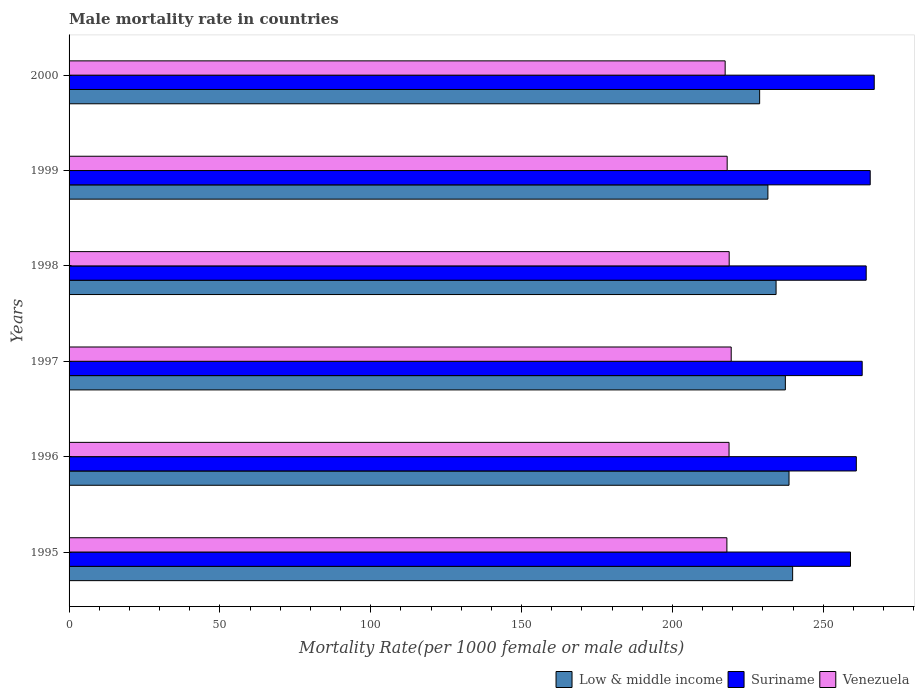Are the number of bars per tick equal to the number of legend labels?
Keep it short and to the point. Yes. How many bars are there on the 4th tick from the top?
Ensure brevity in your answer.  3. How many bars are there on the 2nd tick from the bottom?
Offer a very short reply. 3. In how many cases, is the number of bars for a given year not equal to the number of legend labels?
Offer a very short reply. 0. What is the male mortality rate in Suriname in 1999?
Offer a terse response. 265.58. Across all years, what is the maximum male mortality rate in Low & middle income?
Your answer should be compact. 239.86. Across all years, what is the minimum male mortality rate in Venezuela?
Your answer should be very brief. 217.49. In which year was the male mortality rate in Low & middle income maximum?
Your response must be concise. 1995. What is the total male mortality rate in Suriname in the graph?
Offer a terse response. 1579.68. What is the difference between the male mortality rate in Venezuela in 1996 and that in 2000?
Keep it short and to the point. 1.29. What is the difference between the male mortality rate in Low & middle income in 1997 and the male mortality rate in Suriname in 1999?
Offer a terse response. -28.13. What is the average male mortality rate in Venezuela per year?
Ensure brevity in your answer.  218.47. In the year 1998, what is the difference between the male mortality rate in Venezuela and male mortality rate in Low & middle income?
Give a very brief answer. -15.54. What is the ratio of the male mortality rate in Suriname in 1995 to that in 1999?
Provide a succinct answer. 0.98. Is the male mortality rate in Low & middle income in 1995 less than that in 1997?
Ensure brevity in your answer.  No. Is the difference between the male mortality rate in Venezuela in 1997 and 2000 greater than the difference between the male mortality rate in Low & middle income in 1997 and 2000?
Offer a terse response. No. What is the difference between the highest and the second highest male mortality rate in Venezuela?
Make the answer very short. 0.67. What is the difference between the highest and the lowest male mortality rate in Suriname?
Your answer should be very brief. 7.87. Is the sum of the male mortality rate in Suriname in 1997 and 2000 greater than the maximum male mortality rate in Venezuela across all years?
Provide a short and direct response. Yes. What does the 2nd bar from the top in 1996 represents?
Your answer should be compact. Suriname. What does the 2nd bar from the bottom in 1996 represents?
Your response must be concise. Suriname. What is the difference between two consecutive major ticks on the X-axis?
Give a very brief answer. 50. Does the graph contain any zero values?
Give a very brief answer. No. How many legend labels are there?
Offer a very short reply. 3. What is the title of the graph?
Your response must be concise. Male mortality rate in countries. Does "American Samoa" appear as one of the legend labels in the graph?
Keep it short and to the point. No. What is the label or title of the X-axis?
Offer a terse response. Mortality Rate(per 1000 female or male adults). What is the Mortality Rate(per 1000 female or male adults) in Low & middle income in 1995?
Offer a terse response. 239.86. What is the Mortality Rate(per 1000 female or male adults) of Suriname in 1995?
Offer a very short reply. 259.04. What is the Mortality Rate(per 1000 female or male adults) in Venezuela in 1995?
Provide a short and direct response. 218.07. What is the Mortality Rate(per 1000 female or male adults) of Low & middle income in 1996?
Your response must be concise. 238.67. What is the Mortality Rate(per 1000 female or male adults) of Suriname in 1996?
Your answer should be compact. 260.98. What is the Mortality Rate(per 1000 female or male adults) of Venezuela in 1996?
Offer a very short reply. 218.78. What is the Mortality Rate(per 1000 female or male adults) in Low & middle income in 1997?
Provide a succinct answer. 237.45. What is the Mortality Rate(per 1000 female or male adults) in Suriname in 1997?
Your answer should be very brief. 262.92. What is the Mortality Rate(per 1000 female or male adults) of Venezuela in 1997?
Offer a terse response. 219.5. What is the Mortality Rate(per 1000 female or male adults) of Low & middle income in 1998?
Ensure brevity in your answer.  234.38. What is the Mortality Rate(per 1000 female or male adults) of Suriname in 1998?
Ensure brevity in your answer.  264.25. What is the Mortality Rate(per 1000 female or male adults) of Venezuela in 1998?
Your answer should be very brief. 218.83. What is the Mortality Rate(per 1000 female or male adults) in Low & middle income in 1999?
Ensure brevity in your answer.  231.67. What is the Mortality Rate(per 1000 female or male adults) of Suriname in 1999?
Your response must be concise. 265.58. What is the Mortality Rate(per 1000 female or male adults) in Venezuela in 1999?
Offer a terse response. 218.16. What is the Mortality Rate(per 1000 female or male adults) in Low & middle income in 2000?
Make the answer very short. 228.93. What is the Mortality Rate(per 1000 female or male adults) in Suriname in 2000?
Give a very brief answer. 266.91. What is the Mortality Rate(per 1000 female or male adults) of Venezuela in 2000?
Provide a short and direct response. 217.49. Across all years, what is the maximum Mortality Rate(per 1000 female or male adults) of Low & middle income?
Offer a terse response. 239.86. Across all years, what is the maximum Mortality Rate(per 1000 female or male adults) in Suriname?
Your answer should be compact. 266.91. Across all years, what is the maximum Mortality Rate(per 1000 female or male adults) in Venezuela?
Your answer should be very brief. 219.5. Across all years, what is the minimum Mortality Rate(per 1000 female or male adults) of Low & middle income?
Ensure brevity in your answer.  228.93. Across all years, what is the minimum Mortality Rate(per 1000 female or male adults) of Suriname?
Offer a terse response. 259.04. Across all years, what is the minimum Mortality Rate(per 1000 female or male adults) of Venezuela?
Your answer should be compact. 217.49. What is the total Mortality Rate(per 1000 female or male adults) in Low & middle income in the graph?
Offer a very short reply. 1410.95. What is the total Mortality Rate(per 1000 female or male adults) in Suriname in the graph?
Keep it short and to the point. 1579.68. What is the total Mortality Rate(per 1000 female or male adults) of Venezuela in the graph?
Offer a terse response. 1310.84. What is the difference between the Mortality Rate(per 1000 female or male adults) in Low & middle income in 1995 and that in 1996?
Offer a very short reply. 1.2. What is the difference between the Mortality Rate(per 1000 female or male adults) in Suriname in 1995 and that in 1996?
Provide a succinct answer. -1.94. What is the difference between the Mortality Rate(per 1000 female or male adults) in Venezuela in 1995 and that in 1996?
Keep it short and to the point. -0.71. What is the difference between the Mortality Rate(per 1000 female or male adults) in Low & middle income in 1995 and that in 1997?
Your answer should be compact. 2.41. What is the difference between the Mortality Rate(per 1000 female or male adults) in Suriname in 1995 and that in 1997?
Provide a succinct answer. -3.88. What is the difference between the Mortality Rate(per 1000 female or male adults) of Venezuela in 1995 and that in 1997?
Keep it short and to the point. -1.43. What is the difference between the Mortality Rate(per 1000 female or male adults) of Low & middle income in 1995 and that in 1998?
Your response must be concise. 5.49. What is the difference between the Mortality Rate(per 1000 female or male adults) in Suriname in 1995 and that in 1998?
Ensure brevity in your answer.  -5.21. What is the difference between the Mortality Rate(per 1000 female or male adults) of Venezuela in 1995 and that in 1998?
Your answer should be compact. -0.76. What is the difference between the Mortality Rate(per 1000 female or male adults) in Low & middle income in 1995 and that in 1999?
Provide a succinct answer. 8.2. What is the difference between the Mortality Rate(per 1000 female or male adults) of Suriname in 1995 and that in 1999?
Your response must be concise. -6.54. What is the difference between the Mortality Rate(per 1000 female or male adults) of Venezuela in 1995 and that in 1999?
Offer a terse response. -0.09. What is the difference between the Mortality Rate(per 1000 female or male adults) of Low & middle income in 1995 and that in 2000?
Keep it short and to the point. 10.94. What is the difference between the Mortality Rate(per 1000 female or male adults) of Suriname in 1995 and that in 2000?
Provide a succinct answer. -7.87. What is the difference between the Mortality Rate(per 1000 female or male adults) in Venezuela in 1995 and that in 2000?
Make the answer very short. 0.58. What is the difference between the Mortality Rate(per 1000 female or male adults) of Low & middle income in 1996 and that in 1997?
Offer a terse response. 1.21. What is the difference between the Mortality Rate(per 1000 female or male adults) of Suriname in 1996 and that in 1997?
Your response must be concise. -1.94. What is the difference between the Mortality Rate(per 1000 female or male adults) of Venezuela in 1996 and that in 1997?
Make the answer very short. -0.71. What is the difference between the Mortality Rate(per 1000 female or male adults) of Low & middle income in 1996 and that in 1998?
Your answer should be very brief. 4.29. What is the difference between the Mortality Rate(per 1000 female or male adults) in Suriname in 1996 and that in 1998?
Offer a very short reply. -3.27. What is the difference between the Mortality Rate(per 1000 female or male adults) in Venezuela in 1996 and that in 1998?
Your answer should be very brief. -0.05. What is the difference between the Mortality Rate(per 1000 female or male adults) of Low & middle income in 1996 and that in 1999?
Provide a succinct answer. 7. What is the difference between the Mortality Rate(per 1000 female or male adults) in Suriname in 1996 and that in 1999?
Your answer should be very brief. -4.6. What is the difference between the Mortality Rate(per 1000 female or male adults) in Venezuela in 1996 and that in 1999?
Ensure brevity in your answer.  0.62. What is the difference between the Mortality Rate(per 1000 female or male adults) in Low & middle income in 1996 and that in 2000?
Make the answer very short. 9.74. What is the difference between the Mortality Rate(per 1000 female or male adults) of Suriname in 1996 and that in 2000?
Your answer should be very brief. -5.93. What is the difference between the Mortality Rate(per 1000 female or male adults) of Venezuela in 1996 and that in 2000?
Keep it short and to the point. 1.29. What is the difference between the Mortality Rate(per 1000 female or male adults) of Low & middle income in 1997 and that in 1998?
Make the answer very short. 3.08. What is the difference between the Mortality Rate(per 1000 female or male adults) of Suriname in 1997 and that in 1998?
Keep it short and to the point. -1.33. What is the difference between the Mortality Rate(per 1000 female or male adults) of Venezuela in 1997 and that in 1998?
Your response must be concise. 0.67. What is the difference between the Mortality Rate(per 1000 female or male adults) of Low & middle income in 1997 and that in 1999?
Your answer should be very brief. 5.79. What is the difference between the Mortality Rate(per 1000 female or male adults) in Suriname in 1997 and that in 1999?
Your response must be concise. -2.66. What is the difference between the Mortality Rate(per 1000 female or male adults) in Venezuela in 1997 and that in 1999?
Provide a short and direct response. 1.34. What is the difference between the Mortality Rate(per 1000 female or male adults) of Low & middle income in 1997 and that in 2000?
Your answer should be very brief. 8.53. What is the difference between the Mortality Rate(per 1000 female or male adults) of Suriname in 1997 and that in 2000?
Keep it short and to the point. -4. What is the difference between the Mortality Rate(per 1000 female or male adults) of Venezuela in 1997 and that in 2000?
Provide a short and direct response. 2.01. What is the difference between the Mortality Rate(per 1000 female or male adults) in Low & middle income in 1998 and that in 1999?
Provide a short and direct response. 2.71. What is the difference between the Mortality Rate(per 1000 female or male adults) in Suriname in 1998 and that in 1999?
Keep it short and to the point. -1.33. What is the difference between the Mortality Rate(per 1000 female or male adults) in Venezuela in 1998 and that in 1999?
Make the answer very short. 0.67. What is the difference between the Mortality Rate(per 1000 female or male adults) in Low & middle income in 1998 and that in 2000?
Offer a terse response. 5.45. What is the difference between the Mortality Rate(per 1000 female or male adults) of Suriname in 1998 and that in 2000?
Ensure brevity in your answer.  -2.66. What is the difference between the Mortality Rate(per 1000 female or male adults) of Venezuela in 1998 and that in 2000?
Make the answer very short. 1.34. What is the difference between the Mortality Rate(per 1000 female or male adults) of Low & middle income in 1999 and that in 2000?
Offer a terse response. 2.74. What is the difference between the Mortality Rate(per 1000 female or male adults) of Suriname in 1999 and that in 2000?
Keep it short and to the point. -1.33. What is the difference between the Mortality Rate(per 1000 female or male adults) in Venezuela in 1999 and that in 2000?
Make the answer very short. 0.67. What is the difference between the Mortality Rate(per 1000 female or male adults) in Low & middle income in 1995 and the Mortality Rate(per 1000 female or male adults) in Suriname in 1996?
Keep it short and to the point. -21.12. What is the difference between the Mortality Rate(per 1000 female or male adults) in Low & middle income in 1995 and the Mortality Rate(per 1000 female or male adults) in Venezuela in 1996?
Your response must be concise. 21.08. What is the difference between the Mortality Rate(per 1000 female or male adults) in Suriname in 1995 and the Mortality Rate(per 1000 female or male adults) in Venezuela in 1996?
Keep it short and to the point. 40.26. What is the difference between the Mortality Rate(per 1000 female or male adults) of Low & middle income in 1995 and the Mortality Rate(per 1000 female or male adults) of Suriname in 1997?
Offer a terse response. -23.05. What is the difference between the Mortality Rate(per 1000 female or male adults) of Low & middle income in 1995 and the Mortality Rate(per 1000 female or male adults) of Venezuela in 1997?
Provide a succinct answer. 20.36. What is the difference between the Mortality Rate(per 1000 female or male adults) in Suriname in 1995 and the Mortality Rate(per 1000 female or male adults) in Venezuela in 1997?
Give a very brief answer. 39.54. What is the difference between the Mortality Rate(per 1000 female or male adults) of Low & middle income in 1995 and the Mortality Rate(per 1000 female or male adults) of Suriname in 1998?
Your answer should be very brief. -24.39. What is the difference between the Mortality Rate(per 1000 female or male adults) of Low & middle income in 1995 and the Mortality Rate(per 1000 female or male adults) of Venezuela in 1998?
Provide a short and direct response. 21.03. What is the difference between the Mortality Rate(per 1000 female or male adults) in Suriname in 1995 and the Mortality Rate(per 1000 female or male adults) in Venezuela in 1998?
Your response must be concise. 40.21. What is the difference between the Mortality Rate(per 1000 female or male adults) of Low & middle income in 1995 and the Mortality Rate(per 1000 female or male adults) of Suriname in 1999?
Offer a terse response. -25.72. What is the difference between the Mortality Rate(per 1000 female or male adults) in Low & middle income in 1995 and the Mortality Rate(per 1000 female or male adults) in Venezuela in 1999?
Make the answer very short. 21.7. What is the difference between the Mortality Rate(per 1000 female or male adults) in Suriname in 1995 and the Mortality Rate(per 1000 female or male adults) in Venezuela in 1999?
Ensure brevity in your answer.  40.88. What is the difference between the Mortality Rate(per 1000 female or male adults) of Low & middle income in 1995 and the Mortality Rate(per 1000 female or male adults) of Suriname in 2000?
Offer a terse response. -27.05. What is the difference between the Mortality Rate(per 1000 female or male adults) of Low & middle income in 1995 and the Mortality Rate(per 1000 female or male adults) of Venezuela in 2000?
Your answer should be very brief. 22.37. What is the difference between the Mortality Rate(per 1000 female or male adults) of Suriname in 1995 and the Mortality Rate(per 1000 female or male adults) of Venezuela in 2000?
Provide a short and direct response. 41.55. What is the difference between the Mortality Rate(per 1000 female or male adults) in Low & middle income in 1996 and the Mortality Rate(per 1000 female or male adults) in Suriname in 1997?
Offer a terse response. -24.25. What is the difference between the Mortality Rate(per 1000 female or male adults) in Low & middle income in 1996 and the Mortality Rate(per 1000 female or male adults) in Venezuela in 1997?
Offer a very short reply. 19.17. What is the difference between the Mortality Rate(per 1000 female or male adults) of Suriname in 1996 and the Mortality Rate(per 1000 female or male adults) of Venezuela in 1997?
Offer a very short reply. 41.48. What is the difference between the Mortality Rate(per 1000 female or male adults) of Low & middle income in 1996 and the Mortality Rate(per 1000 female or male adults) of Suriname in 1998?
Offer a terse response. -25.58. What is the difference between the Mortality Rate(per 1000 female or male adults) of Low & middle income in 1996 and the Mortality Rate(per 1000 female or male adults) of Venezuela in 1998?
Ensure brevity in your answer.  19.83. What is the difference between the Mortality Rate(per 1000 female or male adults) of Suriname in 1996 and the Mortality Rate(per 1000 female or male adults) of Venezuela in 1998?
Provide a succinct answer. 42.15. What is the difference between the Mortality Rate(per 1000 female or male adults) of Low & middle income in 1996 and the Mortality Rate(per 1000 female or male adults) of Suriname in 1999?
Keep it short and to the point. -26.91. What is the difference between the Mortality Rate(per 1000 female or male adults) of Low & middle income in 1996 and the Mortality Rate(per 1000 female or male adults) of Venezuela in 1999?
Your answer should be compact. 20.5. What is the difference between the Mortality Rate(per 1000 female or male adults) of Suriname in 1996 and the Mortality Rate(per 1000 female or male adults) of Venezuela in 1999?
Ensure brevity in your answer.  42.82. What is the difference between the Mortality Rate(per 1000 female or male adults) of Low & middle income in 1996 and the Mortality Rate(per 1000 female or male adults) of Suriname in 2000?
Keep it short and to the point. -28.25. What is the difference between the Mortality Rate(per 1000 female or male adults) in Low & middle income in 1996 and the Mortality Rate(per 1000 female or male adults) in Venezuela in 2000?
Keep it short and to the point. 21.17. What is the difference between the Mortality Rate(per 1000 female or male adults) of Suriname in 1996 and the Mortality Rate(per 1000 female or male adults) of Venezuela in 2000?
Your answer should be compact. 43.48. What is the difference between the Mortality Rate(per 1000 female or male adults) in Low & middle income in 1997 and the Mortality Rate(per 1000 female or male adults) in Suriname in 1998?
Keep it short and to the point. -26.8. What is the difference between the Mortality Rate(per 1000 female or male adults) in Low & middle income in 1997 and the Mortality Rate(per 1000 female or male adults) in Venezuela in 1998?
Offer a very short reply. 18.62. What is the difference between the Mortality Rate(per 1000 female or male adults) of Suriname in 1997 and the Mortality Rate(per 1000 female or male adults) of Venezuela in 1998?
Your answer should be compact. 44.09. What is the difference between the Mortality Rate(per 1000 female or male adults) in Low & middle income in 1997 and the Mortality Rate(per 1000 female or male adults) in Suriname in 1999?
Keep it short and to the point. -28.13. What is the difference between the Mortality Rate(per 1000 female or male adults) in Low & middle income in 1997 and the Mortality Rate(per 1000 female or male adults) in Venezuela in 1999?
Offer a terse response. 19.29. What is the difference between the Mortality Rate(per 1000 female or male adults) of Suriname in 1997 and the Mortality Rate(per 1000 female or male adults) of Venezuela in 1999?
Your response must be concise. 44.75. What is the difference between the Mortality Rate(per 1000 female or male adults) of Low & middle income in 1997 and the Mortality Rate(per 1000 female or male adults) of Suriname in 2000?
Provide a short and direct response. -29.46. What is the difference between the Mortality Rate(per 1000 female or male adults) in Low & middle income in 1997 and the Mortality Rate(per 1000 female or male adults) in Venezuela in 2000?
Offer a very short reply. 19.96. What is the difference between the Mortality Rate(per 1000 female or male adults) in Suriname in 1997 and the Mortality Rate(per 1000 female or male adults) in Venezuela in 2000?
Your answer should be compact. 45.42. What is the difference between the Mortality Rate(per 1000 female or male adults) of Low & middle income in 1998 and the Mortality Rate(per 1000 female or male adults) of Suriname in 1999?
Give a very brief answer. -31.21. What is the difference between the Mortality Rate(per 1000 female or male adults) in Low & middle income in 1998 and the Mortality Rate(per 1000 female or male adults) in Venezuela in 1999?
Keep it short and to the point. 16.21. What is the difference between the Mortality Rate(per 1000 female or male adults) of Suriname in 1998 and the Mortality Rate(per 1000 female or male adults) of Venezuela in 1999?
Make the answer very short. 46.09. What is the difference between the Mortality Rate(per 1000 female or male adults) in Low & middle income in 1998 and the Mortality Rate(per 1000 female or male adults) in Suriname in 2000?
Ensure brevity in your answer.  -32.54. What is the difference between the Mortality Rate(per 1000 female or male adults) in Low & middle income in 1998 and the Mortality Rate(per 1000 female or male adults) in Venezuela in 2000?
Give a very brief answer. 16.88. What is the difference between the Mortality Rate(per 1000 female or male adults) in Suriname in 1998 and the Mortality Rate(per 1000 female or male adults) in Venezuela in 2000?
Provide a succinct answer. 46.76. What is the difference between the Mortality Rate(per 1000 female or male adults) of Low & middle income in 1999 and the Mortality Rate(per 1000 female or male adults) of Suriname in 2000?
Offer a very short reply. -35.25. What is the difference between the Mortality Rate(per 1000 female or male adults) in Low & middle income in 1999 and the Mortality Rate(per 1000 female or male adults) in Venezuela in 2000?
Give a very brief answer. 14.17. What is the difference between the Mortality Rate(per 1000 female or male adults) in Suriname in 1999 and the Mortality Rate(per 1000 female or male adults) in Venezuela in 2000?
Offer a terse response. 48.09. What is the average Mortality Rate(per 1000 female or male adults) of Low & middle income per year?
Keep it short and to the point. 235.16. What is the average Mortality Rate(per 1000 female or male adults) of Suriname per year?
Make the answer very short. 263.28. What is the average Mortality Rate(per 1000 female or male adults) of Venezuela per year?
Provide a short and direct response. 218.47. In the year 1995, what is the difference between the Mortality Rate(per 1000 female or male adults) of Low & middle income and Mortality Rate(per 1000 female or male adults) of Suriname?
Keep it short and to the point. -19.18. In the year 1995, what is the difference between the Mortality Rate(per 1000 female or male adults) of Low & middle income and Mortality Rate(per 1000 female or male adults) of Venezuela?
Provide a short and direct response. 21.79. In the year 1995, what is the difference between the Mortality Rate(per 1000 female or male adults) of Suriname and Mortality Rate(per 1000 female or male adults) of Venezuela?
Make the answer very short. 40.97. In the year 1996, what is the difference between the Mortality Rate(per 1000 female or male adults) in Low & middle income and Mortality Rate(per 1000 female or male adults) in Suriname?
Give a very brief answer. -22.31. In the year 1996, what is the difference between the Mortality Rate(per 1000 female or male adults) of Low & middle income and Mortality Rate(per 1000 female or male adults) of Venezuela?
Provide a succinct answer. 19.88. In the year 1996, what is the difference between the Mortality Rate(per 1000 female or male adults) in Suriname and Mortality Rate(per 1000 female or male adults) in Venezuela?
Your response must be concise. 42.19. In the year 1997, what is the difference between the Mortality Rate(per 1000 female or male adults) of Low & middle income and Mortality Rate(per 1000 female or male adults) of Suriname?
Your answer should be very brief. -25.46. In the year 1997, what is the difference between the Mortality Rate(per 1000 female or male adults) in Low & middle income and Mortality Rate(per 1000 female or male adults) in Venezuela?
Your response must be concise. 17.95. In the year 1997, what is the difference between the Mortality Rate(per 1000 female or male adults) in Suriname and Mortality Rate(per 1000 female or male adults) in Venezuela?
Your answer should be very brief. 43.42. In the year 1998, what is the difference between the Mortality Rate(per 1000 female or male adults) in Low & middle income and Mortality Rate(per 1000 female or male adults) in Suriname?
Offer a very short reply. -29.87. In the year 1998, what is the difference between the Mortality Rate(per 1000 female or male adults) in Low & middle income and Mortality Rate(per 1000 female or male adults) in Venezuela?
Your answer should be very brief. 15.54. In the year 1998, what is the difference between the Mortality Rate(per 1000 female or male adults) in Suriname and Mortality Rate(per 1000 female or male adults) in Venezuela?
Make the answer very short. 45.42. In the year 1999, what is the difference between the Mortality Rate(per 1000 female or male adults) in Low & middle income and Mortality Rate(per 1000 female or male adults) in Suriname?
Offer a very short reply. -33.91. In the year 1999, what is the difference between the Mortality Rate(per 1000 female or male adults) in Low & middle income and Mortality Rate(per 1000 female or male adults) in Venezuela?
Offer a terse response. 13.5. In the year 1999, what is the difference between the Mortality Rate(per 1000 female or male adults) in Suriname and Mortality Rate(per 1000 female or male adults) in Venezuela?
Provide a short and direct response. 47.42. In the year 2000, what is the difference between the Mortality Rate(per 1000 female or male adults) in Low & middle income and Mortality Rate(per 1000 female or male adults) in Suriname?
Offer a terse response. -37.99. In the year 2000, what is the difference between the Mortality Rate(per 1000 female or male adults) of Low & middle income and Mortality Rate(per 1000 female or male adults) of Venezuela?
Offer a terse response. 11.43. In the year 2000, what is the difference between the Mortality Rate(per 1000 female or male adults) in Suriname and Mortality Rate(per 1000 female or male adults) in Venezuela?
Ensure brevity in your answer.  49.42. What is the ratio of the Mortality Rate(per 1000 female or male adults) in Suriname in 1995 to that in 1996?
Offer a very short reply. 0.99. What is the ratio of the Mortality Rate(per 1000 female or male adults) of Low & middle income in 1995 to that in 1997?
Your answer should be compact. 1.01. What is the ratio of the Mortality Rate(per 1000 female or male adults) of Venezuela in 1995 to that in 1997?
Provide a short and direct response. 0.99. What is the ratio of the Mortality Rate(per 1000 female or male adults) in Low & middle income in 1995 to that in 1998?
Your response must be concise. 1.02. What is the ratio of the Mortality Rate(per 1000 female or male adults) of Suriname in 1995 to that in 1998?
Your answer should be compact. 0.98. What is the ratio of the Mortality Rate(per 1000 female or male adults) in Venezuela in 1995 to that in 1998?
Provide a succinct answer. 1. What is the ratio of the Mortality Rate(per 1000 female or male adults) of Low & middle income in 1995 to that in 1999?
Your answer should be compact. 1.04. What is the ratio of the Mortality Rate(per 1000 female or male adults) in Suriname in 1995 to that in 1999?
Offer a very short reply. 0.98. What is the ratio of the Mortality Rate(per 1000 female or male adults) in Low & middle income in 1995 to that in 2000?
Offer a very short reply. 1.05. What is the ratio of the Mortality Rate(per 1000 female or male adults) of Suriname in 1995 to that in 2000?
Give a very brief answer. 0.97. What is the ratio of the Mortality Rate(per 1000 female or male adults) in Venezuela in 1995 to that in 2000?
Your answer should be very brief. 1. What is the ratio of the Mortality Rate(per 1000 female or male adults) in Low & middle income in 1996 to that in 1997?
Give a very brief answer. 1.01. What is the ratio of the Mortality Rate(per 1000 female or male adults) of Suriname in 1996 to that in 1997?
Your response must be concise. 0.99. What is the ratio of the Mortality Rate(per 1000 female or male adults) of Low & middle income in 1996 to that in 1998?
Your answer should be compact. 1.02. What is the ratio of the Mortality Rate(per 1000 female or male adults) of Suriname in 1996 to that in 1998?
Give a very brief answer. 0.99. What is the ratio of the Mortality Rate(per 1000 female or male adults) of Low & middle income in 1996 to that in 1999?
Provide a short and direct response. 1.03. What is the ratio of the Mortality Rate(per 1000 female or male adults) of Suriname in 1996 to that in 1999?
Offer a very short reply. 0.98. What is the ratio of the Mortality Rate(per 1000 female or male adults) of Low & middle income in 1996 to that in 2000?
Make the answer very short. 1.04. What is the ratio of the Mortality Rate(per 1000 female or male adults) in Suriname in 1996 to that in 2000?
Offer a terse response. 0.98. What is the ratio of the Mortality Rate(per 1000 female or male adults) in Venezuela in 1996 to that in 2000?
Provide a succinct answer. 1.01. What is the ratio of the Mortality Rate(per 1000 female or male adults) of Low & middle income in 1997 to that in 1998?
Provide a short and direct response. 1.01. What is the ratio of the Mortality Rate(per 1000 female or male adults) in Suriname in 1997 to that in 1998?
Provide a short and direct response. 0.99. What is the ratio of the Mortality Rate(per 1000 female or male adults) in Venezuela in 1997 to that in 1998?
Your response must be concise. 1. What is the ratio of the Mortality Rate(per 1000 female or male adults) of Low & middle income in 1997 to that in 1999?
Ensure brevity in your answer.  1.02. What is the ratio of the Mortality Rate(per 1000 female or male adults) of Suriname in 1997 to that in 1999?
Offer a terse response. 0.99. What is the ratio of the Mortality Rate(per 1000 female or male adults) of Low & middle income in 1997 to that in 2000?
Your answer should be compact. 1.04. What is the ratio of the Mortality Rate(per 1000 female or male adults) of Venezuela in 1997 to that in 2000?
Your answer should be compact. 1.01. What is the ratio of the Mortality Rate(per 1000 female or male adults) in Low & middle income in 1998 to that in 1999?
Your answer should be very brief. 1.01. What is the ratio of the Mortality Rate(per 1000 female or male adults) of Suriname in 1998 to that in 1999?
Your answer should be very brief. 0.99. What is the ratio of the Mortality Rate(per 1000 female or male adults) in Low & middle income in 1998 to that in 2000?
Your answer should be compact. 1.02. What is the ratio of the Mortality Rate(per 1000 female or male adults) of Venezuela in 1998 to that in 2000?
Give a very brief answer. 1.01. What is the difference between the highest and the second highest Mortality Rate(per 1000 female or male adults) in Low & middle income?
Ensure brevity in your answer.  1.2. What is the difference between the highest and the second highest Mortality Rate(per 1000 female or male adults) in Suriname?
Your answer should be compact. 1.33. What is the difference between the highest and the second highest Mortality Rate(per 1000 female or male adults) in Venezuela?
Your answer should be compact. 0.67. What is the difference between the highest and the lowest Mortality Rate(per 1000 female or male adults) in Low & middle income?
Give a very brief answer. 10.94. What is the difference between the highest and the lowest Mortality Rate(per 1000 female or male adults) of Suriname?
Offer a terse response. 7.87. What is the difference between the highest and the lowest Mortality Rate(per 1000 female or male adults) in Venezuela?
Your response must be concise. 2.01. 